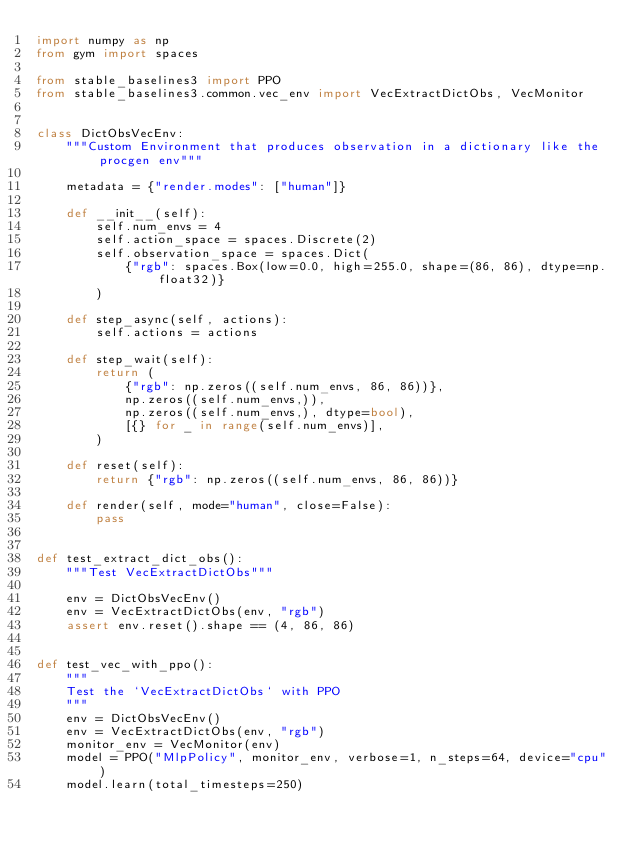Convert code to text. <code><loc_0><loc_0><loc_500><loc_500><_Python_>import numpy as np
from gym import spaces

from stable_baselines3 import PPO
from stable_baselines3.common.vec_env import VecExtractDictObs, VecMonitor


class DictObsVecEnv:
    """Custom Environment that produces observation in a dictionary like the procgen env"""

    metadata = {"render.modes": ["human"]}

    def __init__(self):
        self.num_envs = 4
        self.action_space = spaces.Discrete(2)
        self.observation_space = spaces.Dict(
            {"rgb": spaces.Box(low=0.0, high=255.0, shape=(86, 86), dtype=np.float32)}
        )

    def step_async(self, actions):
        self.actions = actions

    def step_wait(self):
        return (
            {"rgb": np.zeros((self.num_envs, 86, 86))},
            np.zeros((self.num_envs,)),
            np.zeros((self.num_envs,), dtype=bool),
            [{} for _ in range(self.num_envs)],
        )

    def reset(self):
        return {"rgb": np.zeros((self.num_envs, 86, 86))}

    def render(self, mode="human", close=False):
        pass


def test_extract_dict_obs():
    """Test VecExtractDictObs"""

    env = DictObsVecEnv()
    env = VecExtractDictObs(env, "rgb")
    assert env.reset().shape == (4, 86, 86)


def test_vec_with_ppo():
    """
    Test the `VecExtractDictObs` with PPO
    """
    env = DictObsVecEnv()
    env = VecExtractDictObs(env, "rgb")
    monitor_env = VecMonitor(env)
    model = PPO("MlpPolicy", monitor_env, verbose=1, n_steps=64, device="cpu")
    model.learn(total_timesteps=250)
</code> 